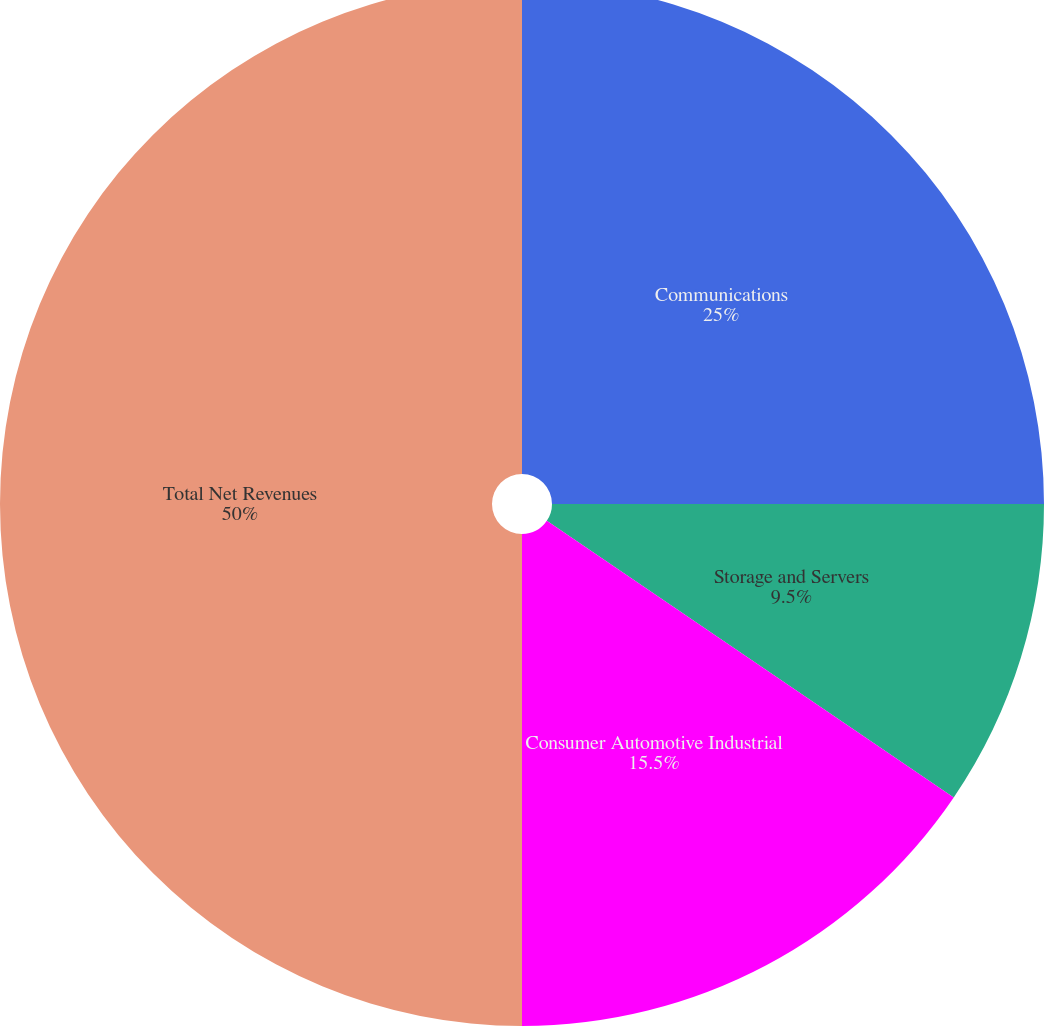Convert chart. <chart><loc_0><loc_0><loc_500><loc_500><pie_chart><fcel>Communications<fcel>Storage and Servers<fcel>Consumer Automotive Industrial<fcel>Total Net Revenues<nl><fcel>25.0%<fcel>9.5%<fcel>15.5%<fcel>50.0%<nl></chart> 